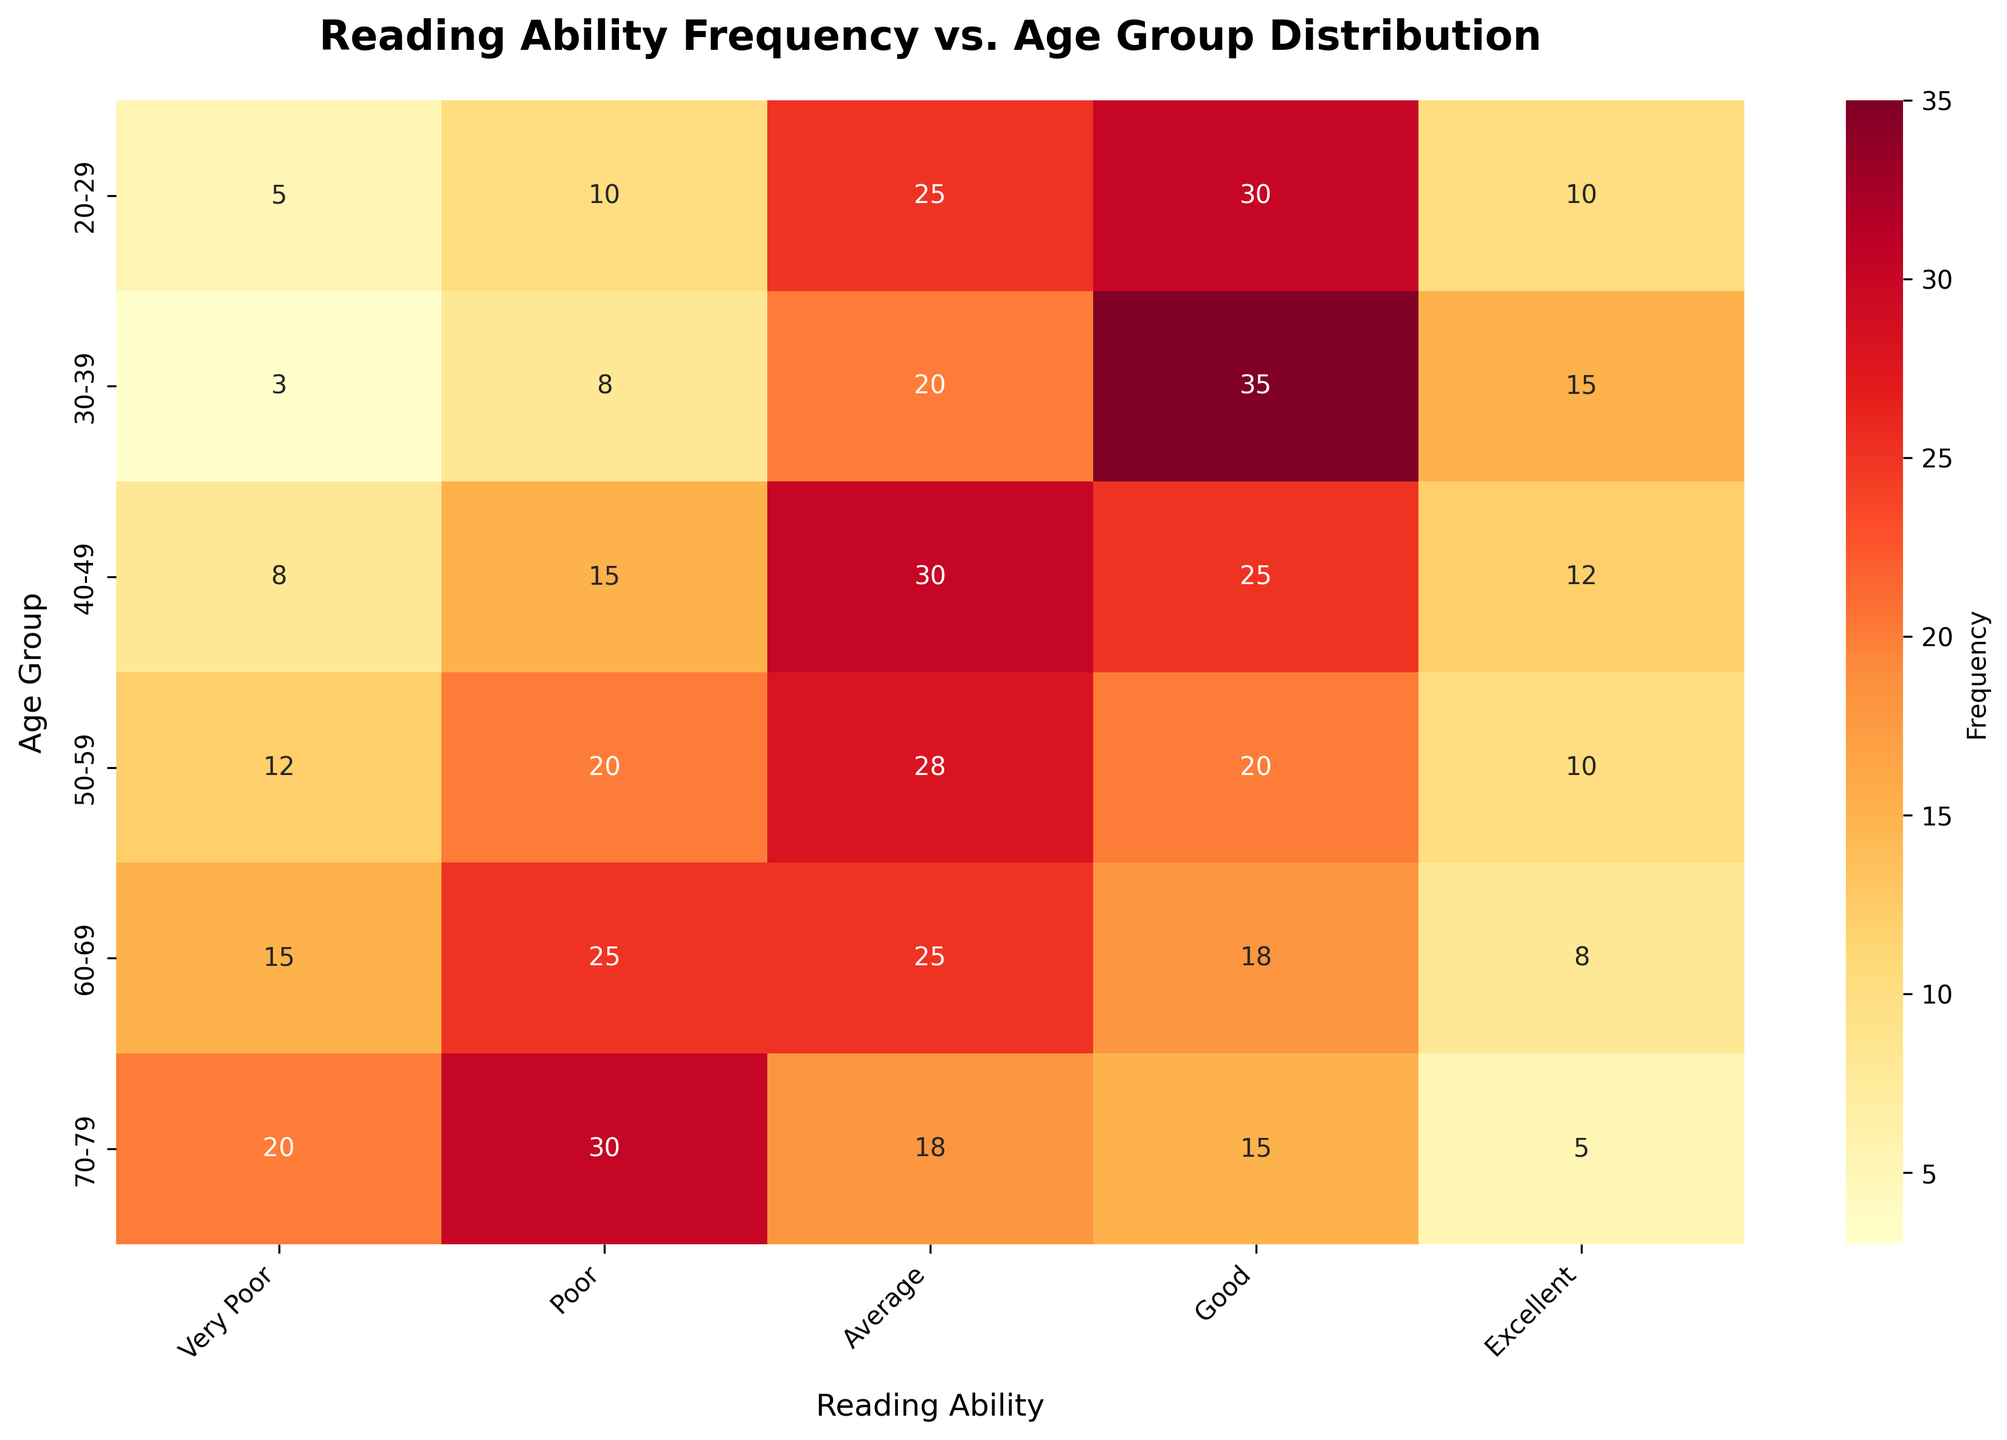What's the title of the heatmap? The title of the heatmap is usually displayed at the top of the figure. In this case, it reads "Reading Ability Frequency vs. Age Group Distribution."
Answer: Reading Ability Frequency vs. Age Group Distribution What age group has the highest frequency of people with very poor reading ability? By looking at the heatmap, the intensity of the color at the intersection of the "Very Poor" column and the age groups can be compared. The highest value is found in the 70-79 age group.
Answer: 70-79 How many total 'Good' readers are there across all age groups? To find the total, sum the values in the "Good" column: 30 + 35 + 25 + 20 + 18 + 15 = 143.
Answer: 143 Which age group has the smallest number of 'Excellent' readers? Compare the values in the "Excellent" column across the different age groups. The smallest number, 5, appears in the 70-79 age group.
Answer: 70-79 How many more 'Poor' readers are there in the age group 60-69 than in the age group 20-29? The values in the "Poor" reading ability for the two age groups are 25 (60-69) and 10 (20-29). Subtract the smaller from the larger: 25 - 10 = 15.
Answer: 15 Which age group has the highest total number of readers (regardless of reading ability)? Sum the values across all columns for each age group, then compare sums: 
20-29: 5+10+25+30+10=80, 
30-39: 3+8+20+35+15=81, 
40-49: 8+15+30+25+12=90, 
50-59: 12+20+28+20+10=90, 
60-69: 15+25+25+18+8=91, 
70-79: 20+30+18+15+5=88. The highest number is 91 for the 60-69 age group.
Answer: 60-69 What is the difference in the number of 'Very Poor' readers between the age groups 40-49 and 50-59? The values for 'Very Poor' readers are 8 (40-49) and 12 (50-59). Subtract the smaller from the larger: 12 - 8 = 4.
Answer: 4 Which reading ability shows the largest number of readers in the age group 30-39? Look across the row for the 30-39 age group. The highest value, 35, is found in the 'Good' column.
Answer: Good In the age group 20-29, how many more readers have 'Average' ability compared to 'Excellent' ability? The values for 'Average' and 'Excellent' abilities in the 20-29 age group are 25 and 10, respectively. Subtract the smaller from the larger: 25 - 10 = 15.
Answer: 15 Which age group has the most balanced distribution of reading abilities, where the differences between the frequency values are the smallest? Compare the variances or range of values within each row (age group). The 40-49 age group has the values 8, 15, 30, 25, 12, which appear more balanced compared to the other age groups where there are wider gaps between the frequencies.
Answer: 40-49 